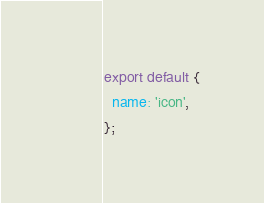Convert code to text. <code><loc_0><loc_0><loc_500><loc_500><_JavaScript_>export default {
  name: 'icon',
};
</code> 